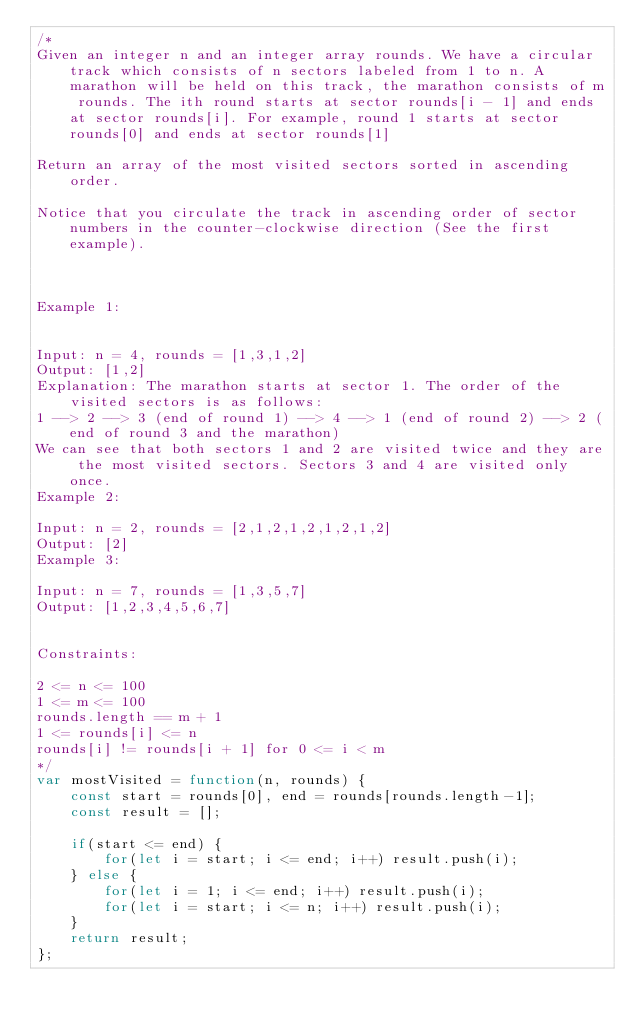<code> <loc_0><loc_0><loc_500><loc_500><_JavaScript_>/*
Given an integer n and an integer array rounds. We have a circular track which consists of n sectors labeled from 1 to n. A marathon will be held on this track, the marathon consists of m rounds. The ith round starts at sector rounds[i - 1] and ends at sector rounds[i]. For example, round 1 starts at sector rounds[0] and ends at sector rounds[1]

Return an array of the most visited sectors sorted in ascending order.

Notice that you circulate the track in ascending order of sector numbers in the counter-clockwise direction (See the first example).

 

Example 1:


Input: n = 4, rounds = [1,3,1,2]
Output: [1,2]
Explanation: The marathon starts at sector 1. The order of the visited sectors is as follows:
1 --> 2 --> 3 (end of round 1) --> 4 --> 1 (end of round 2) --> 2 (end of round 3 and the marathon)
We can see that both sectors 1 and 2 are visited twice and they are the most visited sectors. Sectors 3 and 4 are visited only once.
Example 2:

Input: n = 2, rounds = [2,1,2,1,2,1,2,1,2]
Output: [2]
Example 3:

Input: n = 7, rounds = [1,3,5,7]
Output: [1,2,3,4,5,6,7]
 

Constraints:

2 <= n <= 100
1 <= m <= 100
rounds.length == m + 1
1 <= rounds[i] <= n
rounds[i] != rounds[i + 1] for 0 <= i < m
*/
var mostVisited = function(n, rounds) {
    const start = rounds[0], end = rounds[rounds.length-1];
    const result = [];
    
    if(start <= end) {
        for(let i = start; i <= end; i++) result.push(i);
    } else {
        for(let i = 1; i <= end; i++) result.push(i);
        for(let i = start; i <= n; i++) result.push(i);
    }
    return result;
};
</code> 